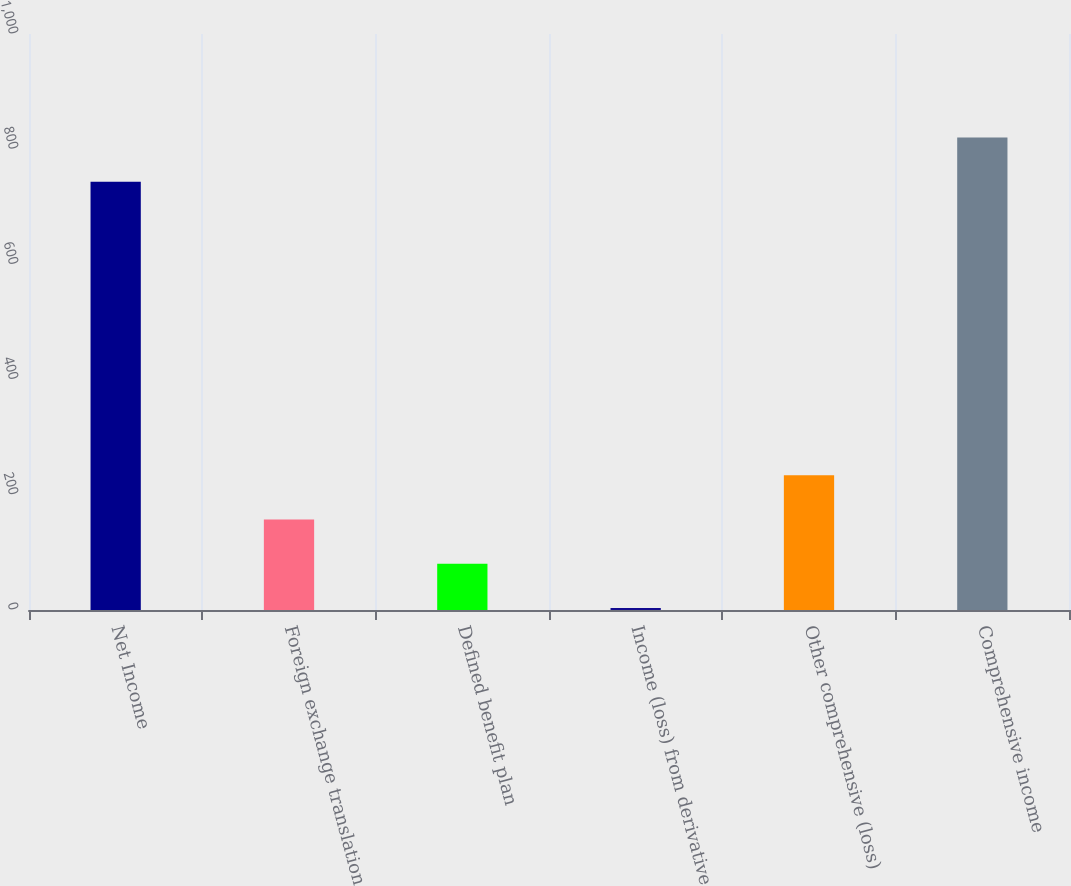Convert chart. <chart><loc_0><loc_0><loc_500><loc_500><bar_chart><fcel>Net Income<fcel>Foreign exchange translation<fcel>Defined benefit plan<fcel>Income (loss) from derivative<fcel>Other comprehensive (loss)<fcel>Comprehensive income<nl><fcel>743.4<fcel>157.04<fcel>80.32<fcel>3.6<fcel>233.76<fcel>820.12<nl></chart> 